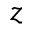Convert formula to latex. <formula><loc_0><loc_0><loc_500><loc_500>z</formula> 